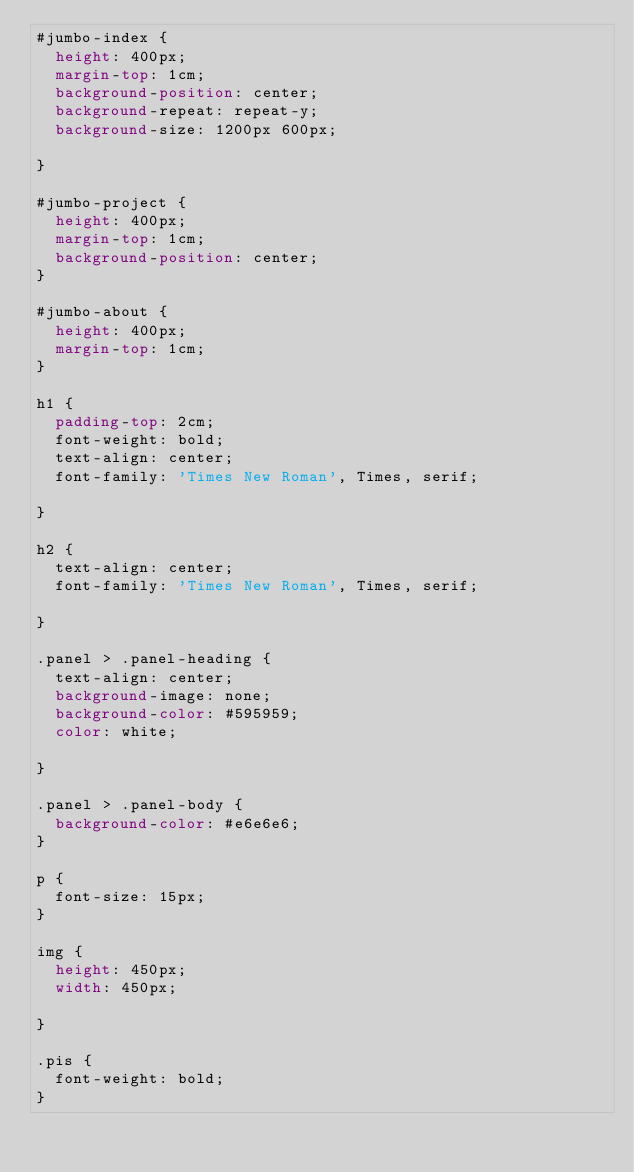Convert code to text. <code><loc_0><loc_0><loc_500><loc_500><_CSS_>#jumbo-index {
  height: 400px;
  margin-top: 1cm;
  background-position: center;
  background-repeat: repeat-y;
  background-size: 1200px 600px;
  
}

#jumbo-project {
  height: 400px;
  margin-top: 1cm;
  background-position: center;
}

#jumbo-about {
  height: 400px;
  margin-top: 1cm;
}

h1 {
  padding-top: 2cm;
  font-weight: bold;
  text-align: center;
  font-family: 'Times New Roman', Times, serif;

}

h2 {
  text-align: center;
  font-family: 'Times New Roman', Times, serif;

}

.panel > .panel-heading {
  text-align: center;
  background-image: none;
  background-color: #595959;
  color: white;

}

.panel > .panel-body {
  background-color: #e6e6e6;
}

p {
  font-size: 15px;
}

img {
  height: 450px;
  width: 450px;
  
}

.pis {
  font-weight: bold;
}</code> 